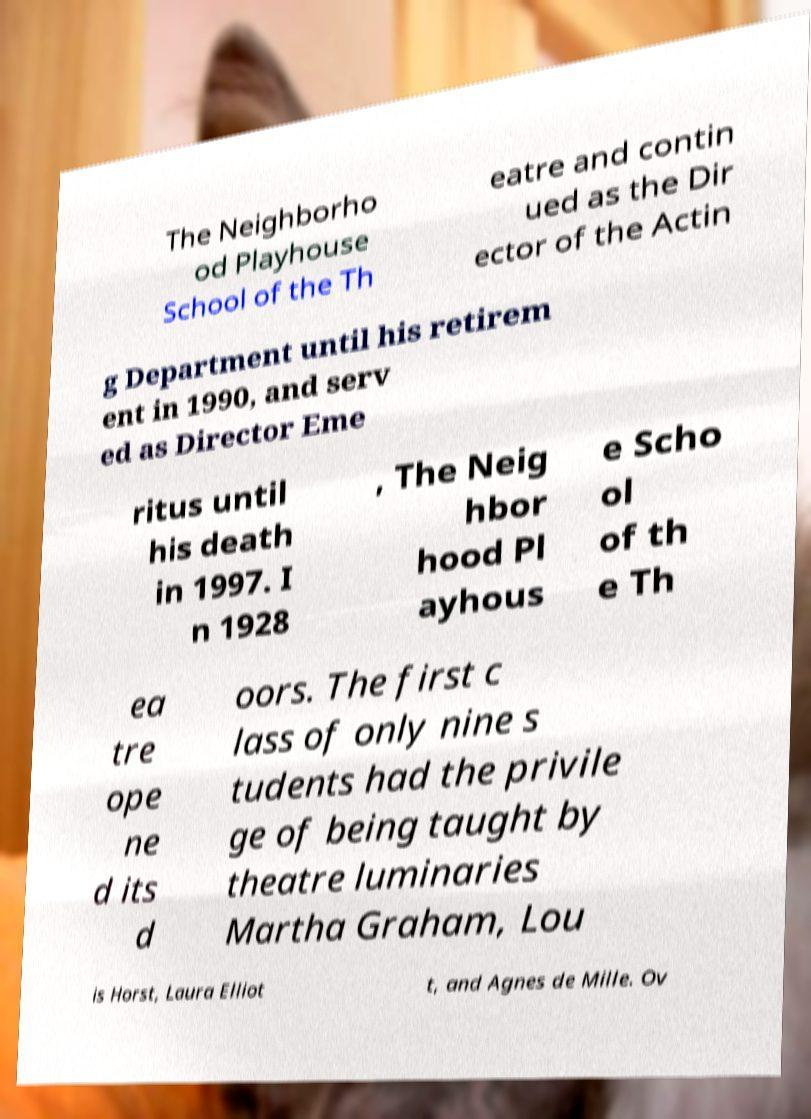I need the written content from this picture converted into text. Can you do that? The Neighborho od Playhouse School of the Th eatre and contin ued as the Dir ector of the Actin g Department until his retirem ent in 1990, and serv ed as Director Eme ritus until his death in 1997. I n 1928 , The Neig hbor hood Pl ayhous e Scho ol of th e Th ea tre ope ne d its d oors. The first c lass of only nine s tudents had the privile ge of being taught by theatre luminaries Martha Graham, Lou is Horst, Laura Elliot t, and Agnes de Mille. Ov 